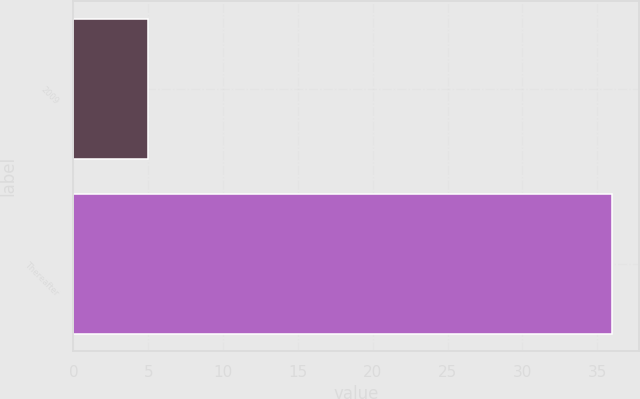Convert chart. <chart><loc_0><loc_0><loc_500><loc_500><bar_chart><fcel>2009<fcel>Thereafter<nl><fcel>5<fcel>36<nl></chart> 